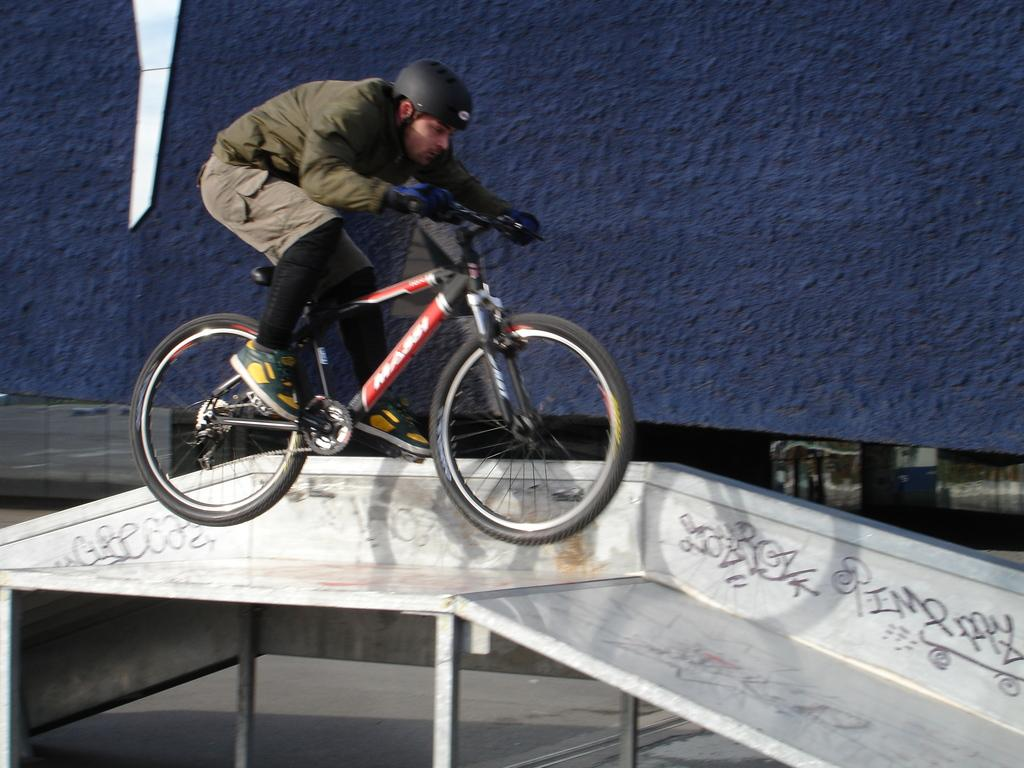Who is present in the image? There is a person in the image. What type of clothing is the person wearing? The person is wearing a jacket and a helmet. What activity is the person engaged in? The person is sitting on a bicycle. What can be seen in the background of the image? There is a building in the background of the image. How many balls are visible in the image? There are no balls present in the image. What point is the person trying to make in the image? The image does not depict a situation where the person is making a point or conveying a message. 